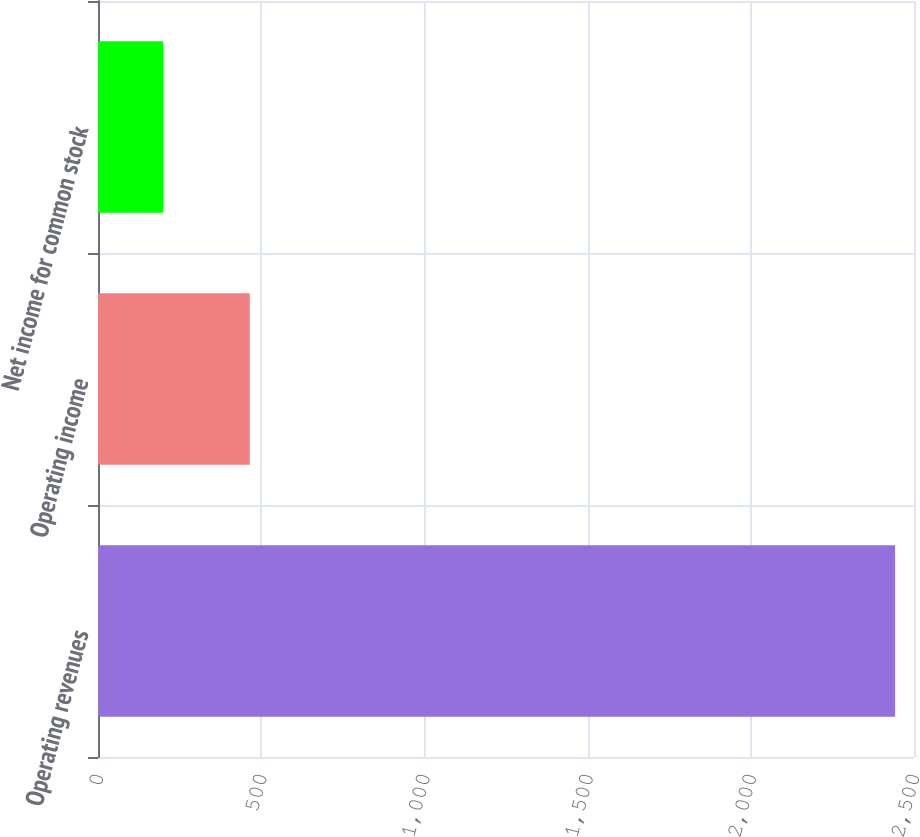Convert chart. <chart><loc_0><loc_0><loc_500><loc_500><bar_chart><fcel>Operating revenues<fcel>Operating income<fcel>Net income for common stock<nl><fcel>2442<fcel>465<fcel>200<nl></chart> 